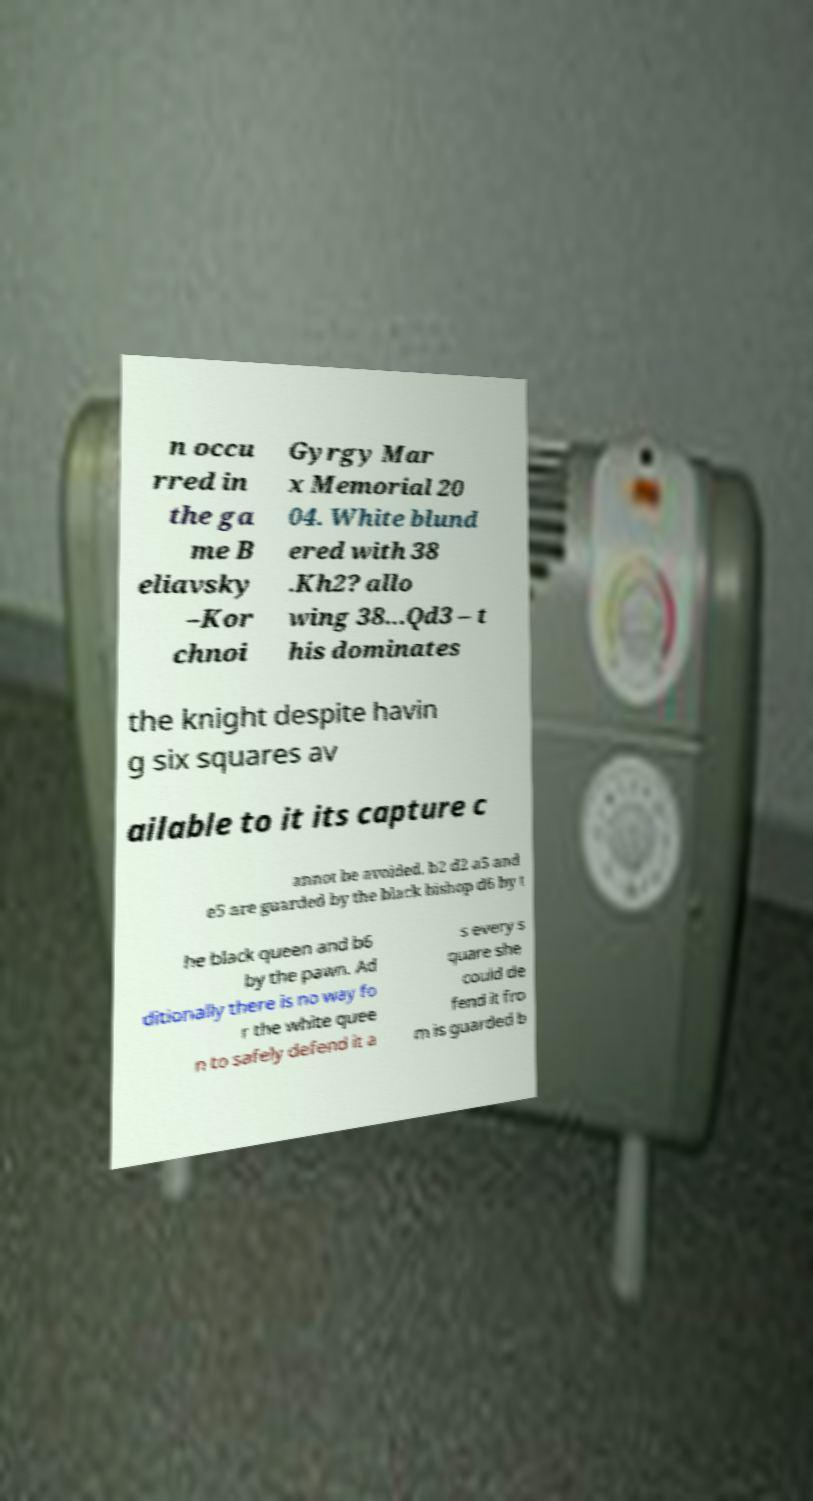Could you extract and type out the text from this image? n occu rred in the ga me B eliavsky –Kor chnoi Gyrgy Mar x Memorial 20 04. White blund ered with 38 .Kh2? allo wing 38...Qd3 – t his dominates the knight despite havin g six squares av ailable to it its capture c annot be avoided. b2 d2 a5 and e5 are guarded by the black bishop d6 by t he black queen and b6 by the pawn. Ad ditionally there is no way fo r the white quee n to safely defend it a s every s quare she could de fend it fro m is guarded b 